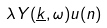<formula> <loc_0><loc_0><loc_500><loc_500>\lambda Y ( \underline { k } , \omega ) u ( n )</formula> 